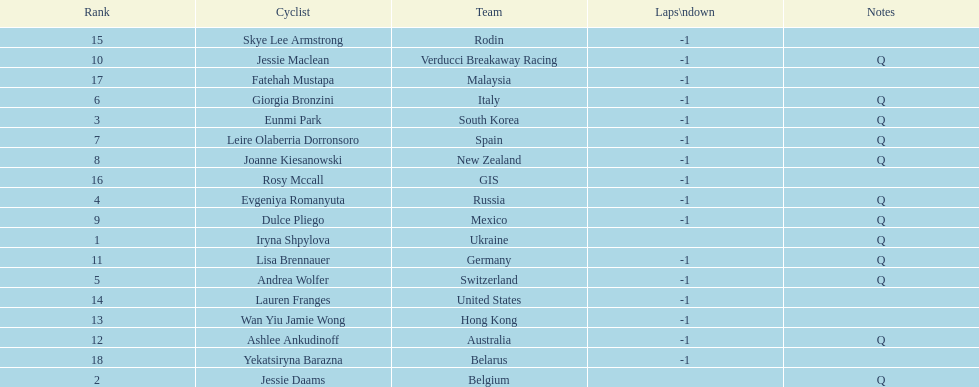Who was the top ranked competitor in this race? Iryna Shpylova. 